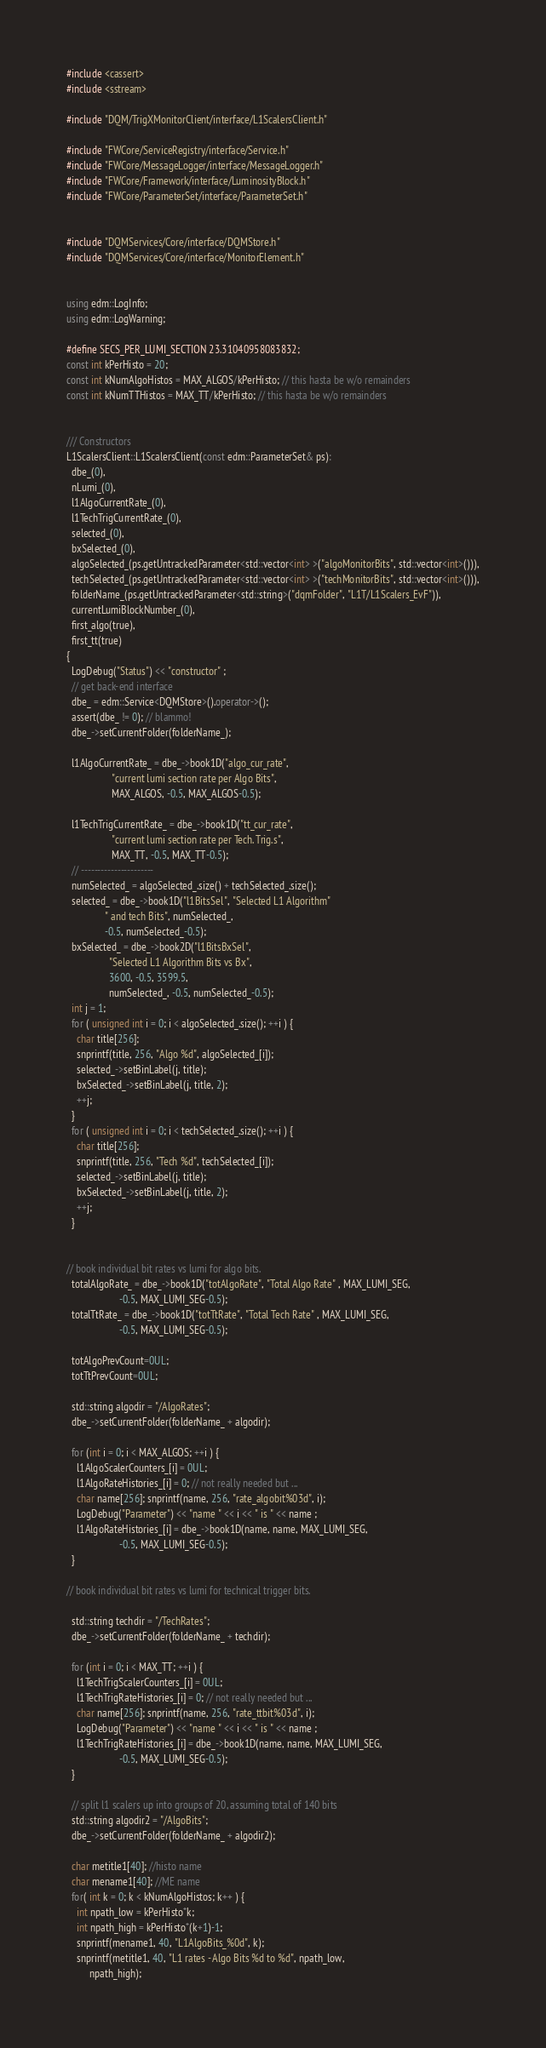<code> <loc_0><loc_0><loc_500><loc_500><_C++_>#include <cassert>
#include <sstream>

#include "DQM/TrigXMonitorClient/interface/L1ScalersClient.h"

#include "FWCore/ServiceRegistry/interface/Service.h"
#include "FWCore/MessageLogger/interface/MessageLogger.h"
#include "FWCore/Framework/interface/LuminosityBlock.h"
#include "FWCore/ParameterSet/interface/ParameterSet.h"


#include "DQMServices/Core/interface/DQMStore.h"
#include "DQMServices/Core/interface/MonitorElement.h"


using edm::LogInfo;
using edm::LogWarning;

#define SECS_PER_LUMI_SECTION 23.31040958083832;
const int kPerHisto = 20;
const int kNumAlgoHistos = MAX_ALGOS/kPerHisto; // this hasta be w/o remainders
const int kNumTTHistos = MAX_TT/kPerHisto; // this hasta be w/o remainders


/// Constructors
L1ScalersClient::L1ScalersClient(const edm::ParameterSet& ps):
  dbe_(0),
  nLumi_(0),
  l1AlgoCurrentRate_(0),
  l1TechTrigCurrentRate_(0),
  selected_(0),
  bxSelected_(0),
  algoSelected_(ps.getUntrackedParameter<std::vector<int> >("algoMonitorBits", std::vector<int>())),
  techSelected_(ps.getUntrackedParameter<std::vector<int> >("techMonitorBits", std::vector<int>())),
  folderName_(ps.getUntrackedParameter<std::string>("dqmFolder", "L1T/L1Scalers_EvF")),
  currentLumiBlockNumber_(0),
  first_algo(true),
  first_tt(true)
{
  LogDebug("Status") << "constructor" ;
  // get back-end interface
  dbe_ = edm::Service<DQMStore>().operator->();
  assert(dbe_ != 0); // blammo!
  dbe_->setCurrentFolder(folderName_);

  l1AlgoCurrentRate_ = dbe_->book1D("algo_cur_rate", 
			      "current lumi section rate per Algo Bits",
			      MAX_ALGOS, -0.5, MAX_ALGOS-0.5);

  l1TechTrigCurrentRate_ = dbe_->book1D("tt_cur_rate", 
			      "current lumi section rate per Tech. Trig.s",
			      MAX_TT, -0.5, MAX_TT-0.5);
  // ----------------------
  numSelected_ = algoSelected_.size() + techSelected_.size();
  selected_ = dbe_->book1D("l1BitsSel", "Selected L1 Algorithm"
			   " and tech Bits", numSelected_,
			   -0.5, numSelected_-0.5);
  bxSelected_ = dbe_->book2D("l1BitsBxSel", 
			     "Selected L1 Algorithm Bits vs Bx", 
			     3600, -0.5, 3599.5,
			     numSelected_, -0.5, numSelected_-0.5);
  int j = 1;
  for ( unsigned int i = 0; i < algoSelected_.size(); ++i ) {
    char title[256];
    snprintf(title, 256, "Algo %d", algoSelected_[i]);
    selected_->setBinLabel(j, title);
    bxSelected_->setBinLabel(j, title, 2);
    ++j;
  }
  for ( unsigned int i = 0; i < techSelected_.size(); ++i ) {
    char title[256];
    snprintf(title, 256, "Tech %d", techSelected_[i]);
    selected_->setBinLabel(j, title);
    bxSelected_->setBinLabel(j, title, 2);
    ++j;
  }


// book individual bit rates vs lumi for algo bits.
  totalAlgoRate_ = dbe_->book1D("totAlgoRate", "Total Algo Rate" , MAX_LUMI_SEG, 
				     -0.5, MAX_LUMI_SEG-0.5);
  totalTtRate_ = dbe_->book1D("totTtRate", "Total Tech Rate" , MAX_LUMI_SEG, 
				     -0.5, MAX_LUMI_SEG-0.5);

  totAlgoPrevCount=0UL;
  totTtPrevCount=0UL;

  std::string algodir = "/AlgoRates";
  dbe_->setCurrentFolder(folderName_ + algodir);

  for (int i = 0; i < MAX_ALGOS; ++i ) {
    l1AlgoScalerCounters_[i] = 0UL;
    l1AlgoRateHistories_[i] = 0; // not really needed but ...
    char name[256]; snprintf(name, 256, "rate_algobit%03d", i);
    LogDebug("Parameter") << "name " << i << " is " << name ;
    l1AlgoRateHistories_[i] = dbe_->book1D(name, name, MAX_LUMI_SEG, 
				     -0.5, MAX_LUMI_SEG-0.5);
  }

// book individual bit rates vs lumi for technical trigger bits.

  std::string techdir = "/TechRates";
  dbe_->setCurrentFolder(folderName_ + techdir);

  for (int i = 0; i < MAX_TT; ++i ) {
    l1TechTrigScalerCounters_[i] = 0UL;
    l1TechTrigRateHistories_[i] = 0; // not really needed but ...
    char name[256]; snprintf(name, 256, "rate_ttbit%03d", i);
    LogDebug("Parameter") << "name " << i << " is " << name ;
    l1TechTrigRateHistories_[i] = dbe_->book1D(name, name, MAX_LUMI_SEG, 
				     -0.5, MAX_LUMI_SEG-0.5);
  }

  // split l1 scalers up into groups of 20, assuming total of 140 bits
  std::string algodir2 = "/AlgoBits";
  dbe_->setCurrentFolder(folderName_ + algodir2);

  char metitle1[40]; //histo name
  char mename1[40]; //ME name
  for( int k = 0; k < kNumAlgoHistos; k++ ) {
    int npath_low = kPerHisto*k;
    int npath_high = kPerHisto*(k+1)-1;
    snprintf(mename1, 40, "L1AlgoBits_%0d", k);
    snprintf(metitle1, 40, "L1 rates - Algo Bits %d to %d", npath_low, 
	     npath_high);</code> 